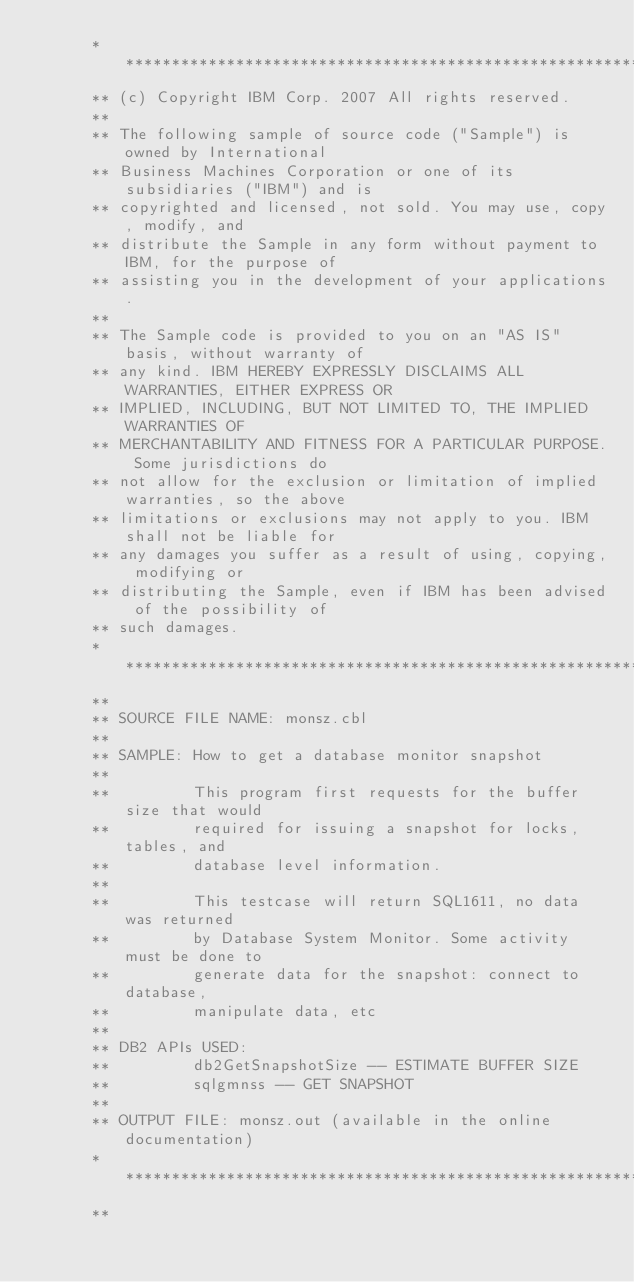Convert code to text. <code><loc_0><loc_0><loc_500><loc_500><_COBOL_>      ***********************************************************************
      ** (c) Copyright IBM Corp. 2007 All rights reserved.
      ** 
      ** The following sample of source code ("Sample") is owned by International 
      ** Business Machines Corporation or one of its subsidiaries ("IBM") and is 
      ** copyrighted and licensed, not sold. You may use, copy, modify, and 
      ** distribute the Sample in any form without payment to IBM, for the purpose of 
      ** assisting you in the development of your applications.
      ** 
      ** The Sample code is provided to you on an "AS IS" basis, without warranty of 
      ** any kind. IBM HEREBY EXPRESSLY DISCLAIMS ALL WARRANTIES, EITHER EXPRESS OR 
      ** IMPLIED, INCLUDING, BUT NOT LIMITED TO, THE IMPLIED WARRANTIES OF 
      ** MERCHANTABILITY AND FITNESS FOR A PARTICULAR PURPOSE. Some jurisdictions do 
      ** not allow for the exclusion or limitation of implied warranties, so the above 
      ** limitations or exclusions may not apply to you. IBM shall not be liable for 
      ** any damages you suffer as a result of using, copying, modifying or 
      ** distributing the Sample, even if IBM has been advised of the possibility of 
      ** such damages.
      ***********************************************************************
      **
      ** SOURCE FILE NAME: monsz.cbl 
      **
      ** SAMPLE: How to get a database monitor snapshot
      **
      **         This program first requests for the buffer size that would
      **         required for issuing a snapshot for locks, tables, and 
      **         database level information.
      **
      **         This testcase will return SQL1611, no data was returned
      **         by Database System Monitor. Some activity must be done to
      **         generate data for the snapshot: connect to database, 
      **         manipulate data, etc
      **
      ** DB2 APIs USED:
      **         db2GetSnapshotSize -- ESTIMATE BUFFER SIZE
      **         sqlgmnss -- GET SNAPSHOT
      **
      ** OUTPUT FILE: monsz.out (available in the online documentation)
      ***********************************************************************
      **</code> 